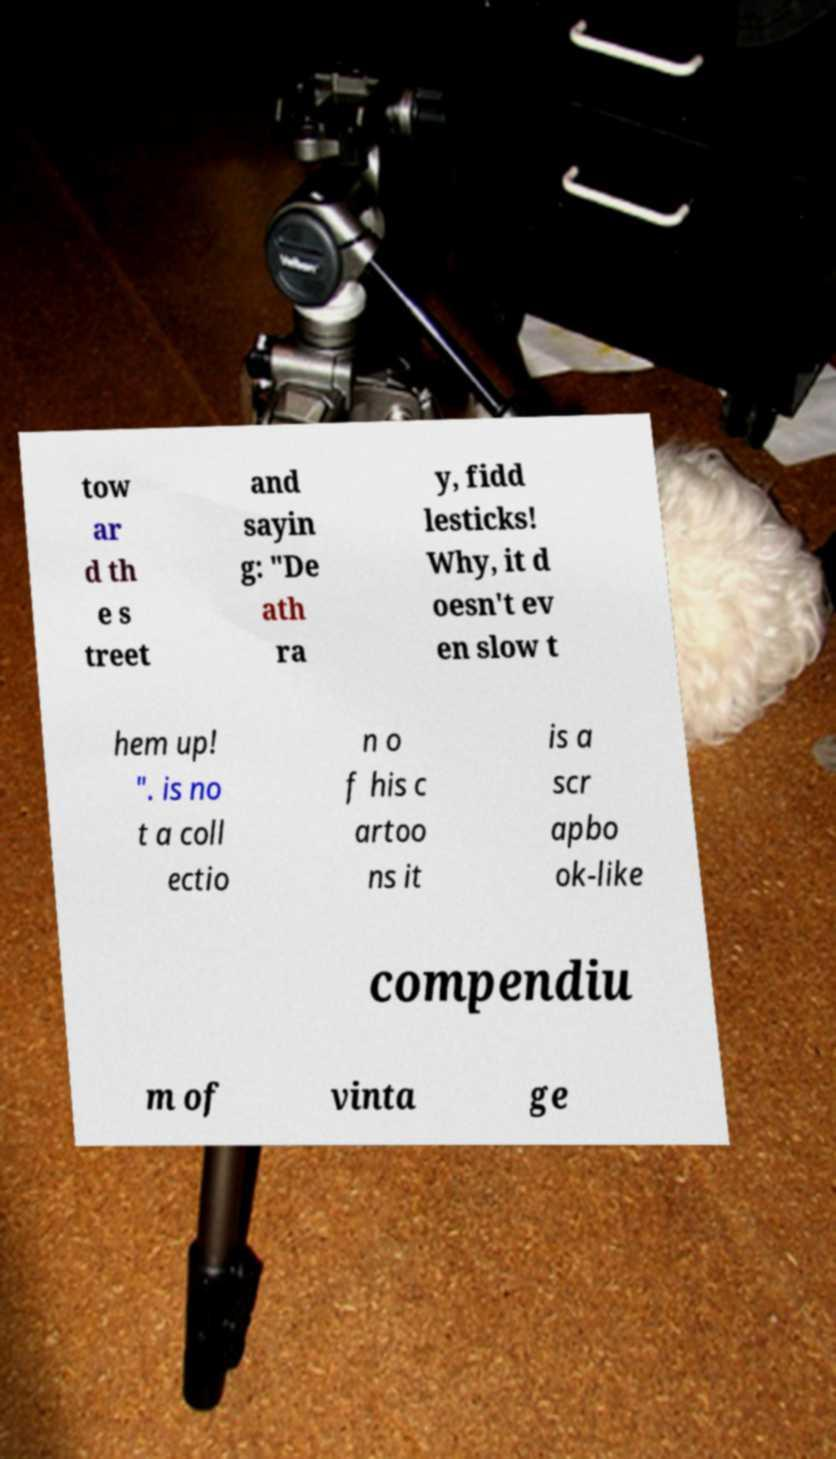Could you extract and type out the text from this image? tow ar d th e s treet and sayin g: "De ath ra y, fidd lesticks! Why, it d oesn't ev en slow t hem up! ". is no t a coll ectio n o f his c artoo ns it is a scr apbo ok-like compendiu m of vinta ge 